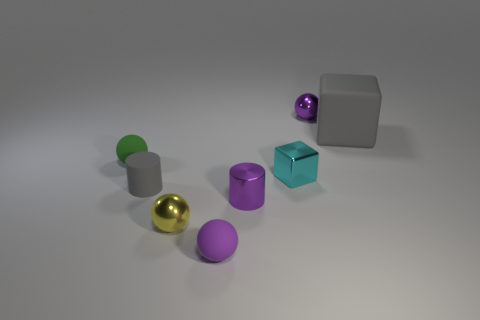Subtract all yellow spheres. Subtract all blue cylinders. How many spheres are left? 3 Add 2 small brown rubber spheres. How many objects exist? 10 Subtract all cubes. How many objects are left? 6 Subtract 2 purple balls. How many objects are left? 6 Subtract all large brown balls. Subtract all cylinders. How many objects are left? 6 Add 1 cyan metal blocks. How many cyan metal blocks are left? 2 Add 7 tiny green balls. How many tiny green balls exist? 8 